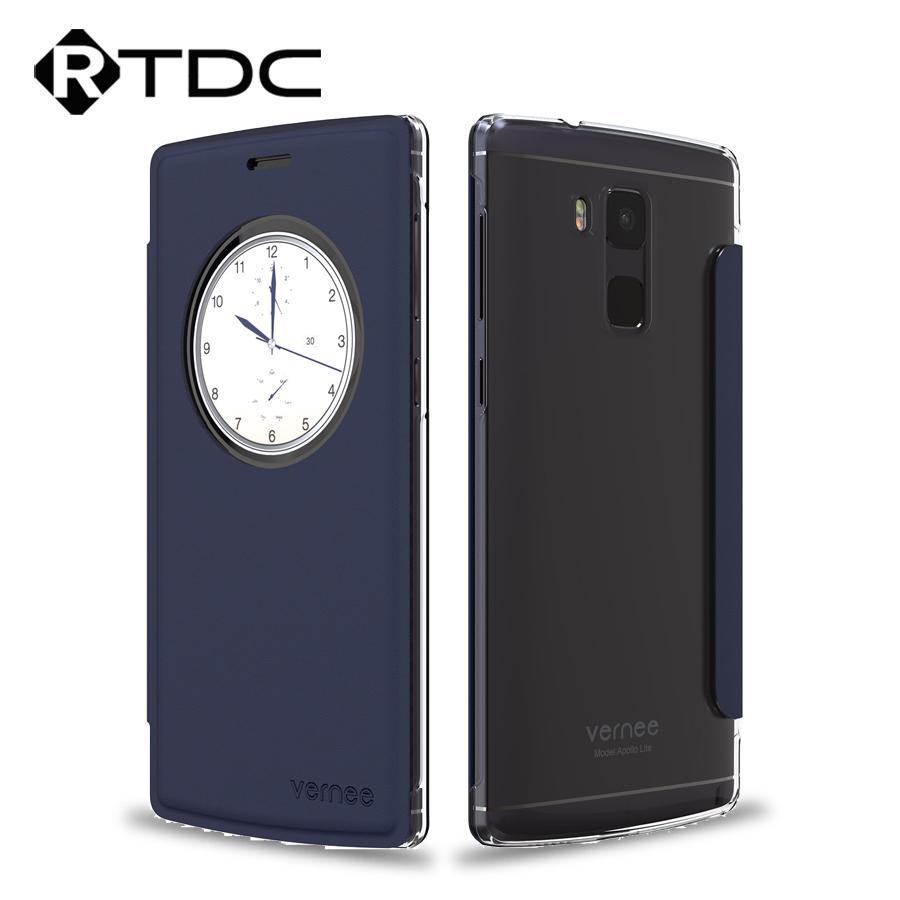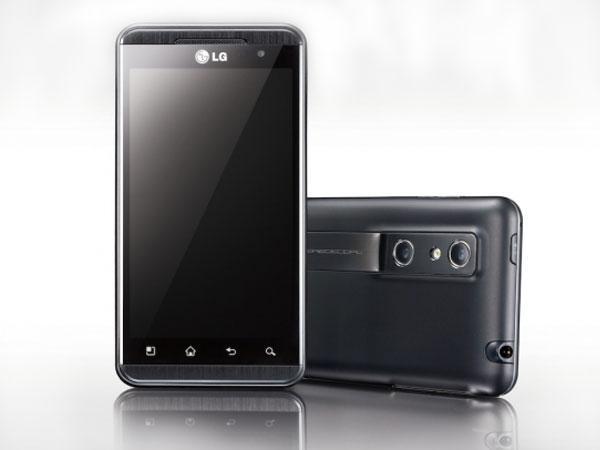The first image is the image on the left, the second image is the image on the right. Evaluate the accuracy of this statement regarding the images: "The left and right image contains the same number of cell phones.". Is it true? Answer yes or no. Yes. The first image is the image on the left, the second image is the image on the right. For the images shown, is this caption "The right image shows a wallet phone case that is open with no cell phone in it." true? Answer yes or no. No. 